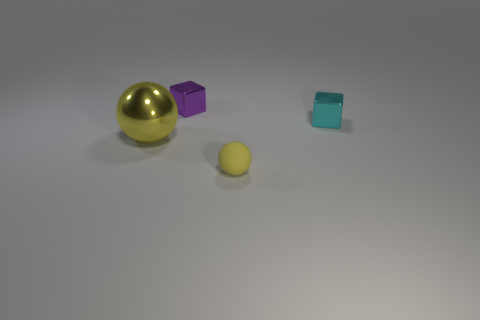What shape is the tiny purple thing that is the same material as the big sphere?
Ensure brevity in your answer.  Cube. Do the cyan shiny object and the yellow object that is on the left side of the tiny ball have the same shape?
Offer a very short reply. No. What is the material of the cube to the right of the sphere on the right side of the small purple shiny cube?
Your answer should be very brief. Metal. What number of other objects are there of the same shape as the tiny cyan shiny object?
Offer a terse response. 1. Is the shape of the large thing that is in front of the purple object the same as the thing that is in front of the yellow metal object?
Your answer should be compact. Yes. Are there any other things that have the same material as the small cyan thing?
Offer a very short reply. Yes. What material is the small cyan object?
Keep it short and to the point. Metal. There is a small block behind the small cyan thing; what is its material?
Your answer should be compact. Metal. Is there any other thing that is the same color as the large shiny ball?
Your response must be concise. Yes. The cyan block that is made of the same material as the large sphere is what size?
Make the answer very short. Small. 